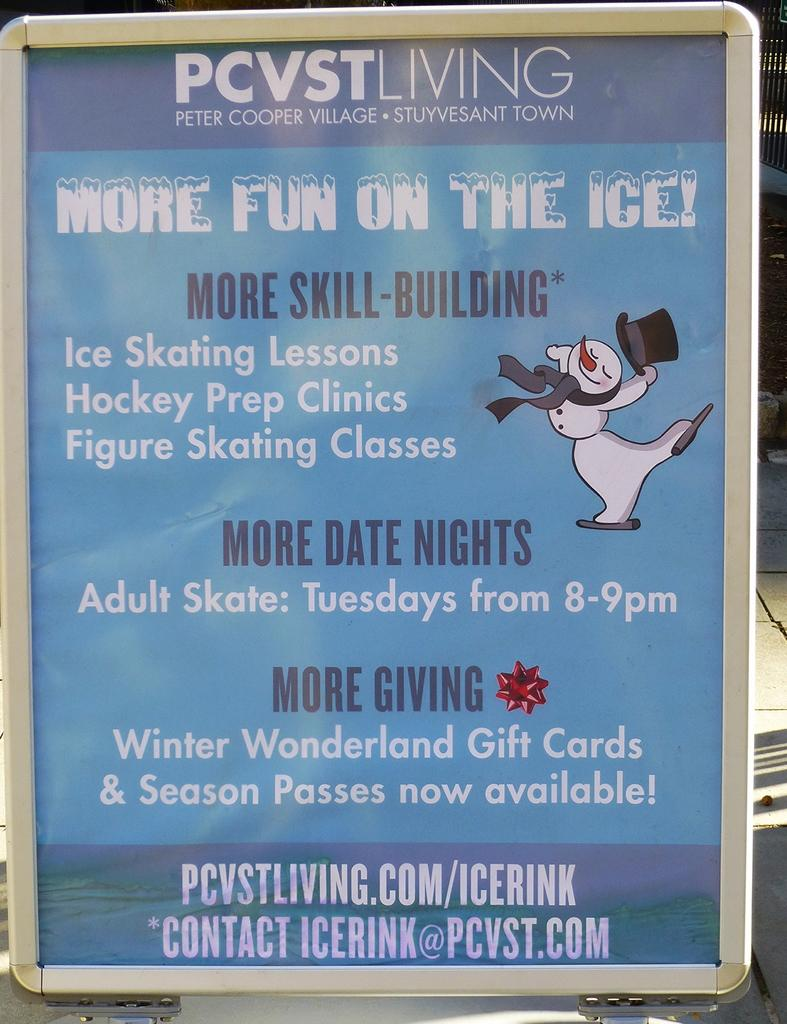<image>
Share a concise interpretation of the image provided. An advertisement for PCVS Living talks about some ice skating events coming up. 